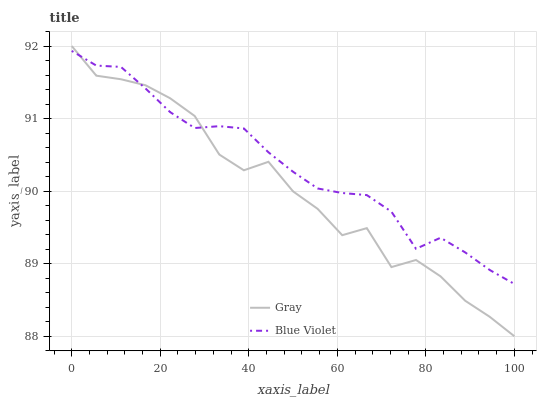Does Gray have the minimum area under the curve?
Answer yes or no. Yes. Does Blue Violet have the maximum area under the curve?
Answer yes or no. Yes. Does Blue Violet have the minimum area under the curve?
Answer yes or no. No. Is Blue Violet the smoothest?
Answer yes or no. Yes. Is Gray the roughest?
Answer yes or no. Yes. Is Blue Violet the roughest?
Answer yes or no. No. Does Gray have the lowest value?
Answer yes or no. Yes. Does Blue Violet have the lowest value?
Answer yes or no. No. Does Gray have the highest value?
Answer yes or no. Yes. Does Blue Violet have the highest value?
Answer yes or no. No. Does Gray intersect Blue Violet?
Answer yes or no. Yes. Is Gray less than Blue Violet?
Answer yes or no. No. Is Gray greater than Blue Violet?
Answer yes or no. No. 